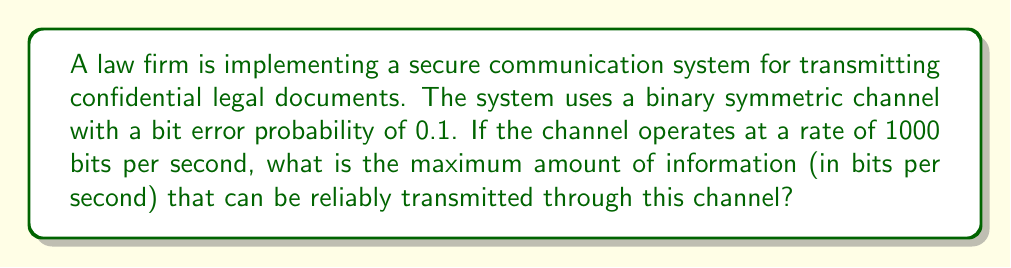Help me with this question. To solve this problem, we need to use the concept of channel capacity from information theory. For a binary symmetric channel (BSC), the channel capacity is given by the formula:

$$C = 1 - H(p)$$

Where $C$ is the channel capacity in bits per channel use, and $H(p)$ is the binary entropy function with $p$ being the bit error probability.

The binary entropy function is defined as:

$$H(p) = -p \log_2(p) - (1-p) \log_2(1-p)$$

Given:
- Bit error probability, $p = 0.1$
- Channel rate = 1000 bits per second

Steps:
1. Calculate $H(p)$:
   $$H(0.1) = -0.1 \log_2(0.1) - 0.9 \log_2(0.9)$$
   $$= -0.1 \cdot (-3.32193) - 0.9 \cdot (-0.15200)$$
   $$= 0.33219 + 0.13680$$
   $$= 0.46899$$

2. Calculate the channel capacity per channel use:
   $$C = 1 - H(p) = 1 - 0.46899 = 0.53101$$

3. Convert the capacity to bits per second:
   Since the channel operates at 1000 bits per second, we multiply the capacity by 1000:
   $$\text{Capacity (bits/second)} = 0.53101 \cdot 1000 = 531.01$$

Therefore, the maximum amount of information that can be reliably transmitted through this channel is approximately 531.01 bits per second.
Answer: 531.01 bits per second 